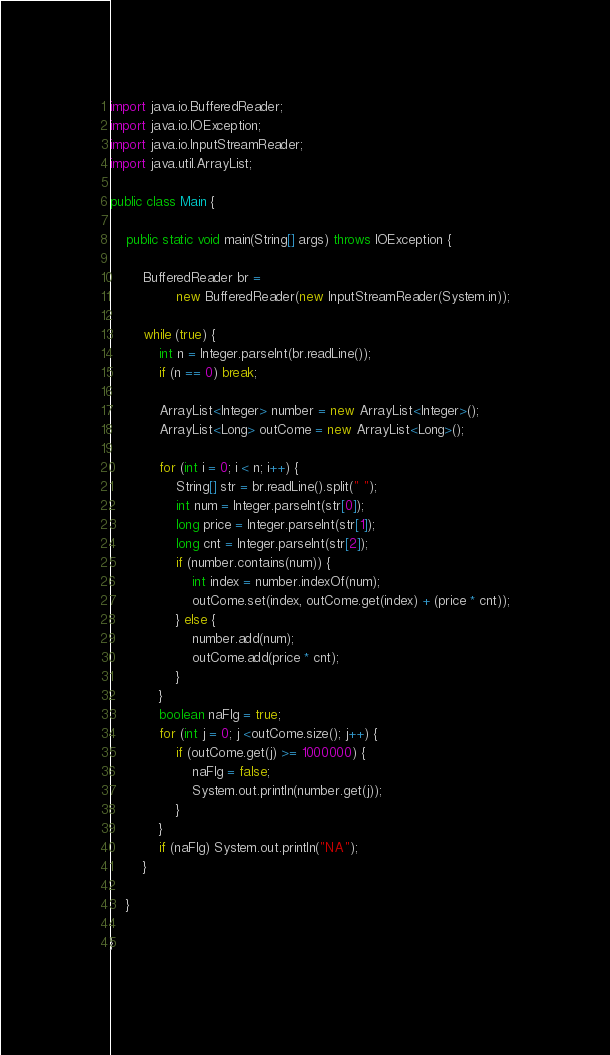<code> <loc_0><loc_0><loc_500><loc_500><_Java_>import java.io.BufferedReader;
import java.io.IOException;
import java.io.InputStreamReader;
import java.util.ArrayList;

public class Main {

	public static void main(String[] args) throws IOException {

		BufferedReader br =
				new BufferedReader(new InputStreamReader(System.in));

		while (true) {
			int n = Integer.parseInt(br.readLine());
			if (n == 0) break;

			ArrayList<Integer> number = new ArrayList<Integer>();
			ArrayList<Long> outCome = new ArrayList<Long>();

			for (int i = 0; i < n; i++) {
				String[] str = br.readLine().split(" ");
				int num = Integer.parseInt(str[0]);
				long price = Integer.parseInt(str[1]);
				long cnt = Integer.parseInt(str[2]);
				if (number.contains(num)) {
					int index = number.indexOf(num);
					outCome.set(index, outCome.get(index) + (price * cnt));
				} else {
					number.add(num);
					outCome.add(price * cnt);
				}
			}
			boolean naFlg = true;
			for (int j = 0; j <outCome.size(); j++) {
				if (outCome.get(j) >= 1000000) {
					naFlg = false;
					System.out.println(number.get(j));
				}
			}
			if (naFlg) System.out.println("NA");
		}

	}

}</code> 